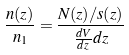<formula> <loc_0><loc_0><loc_500><loc_500>\frac { n ( z ) } { n _ { 1 } } = \frac { N ( z ) / s ( z ) } { \frac { d V } { d z } d z }</formula> 